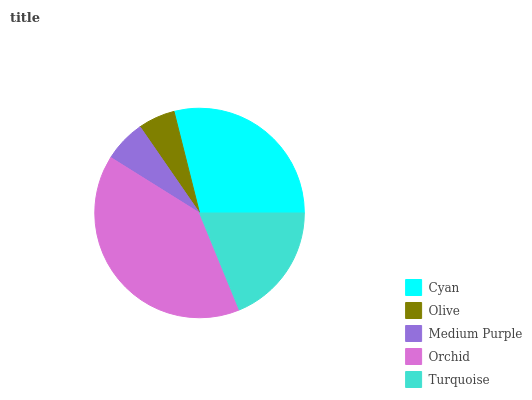Is Olive the minimum?
Answer yes or no. Yes. Is Orchid the maximum?
Answer yes or no. Yes. Is Medium Purple the minimum?
Answer yes or no. No. Is Medium Purple the maximum?
Answer yes or no. No. Is Medium Purple greater than Olive?
Answer yes or no. Yes. Is Olive less than Medium Purple?
Answer yes or no. Yes. Is Olive greater than Medium Purple?
Answer yes or no. No. Is Medium Purple less than Olive?
Answer yes or no. No. Is Turquoise the high median?
Answer yes or no. Yes. Is Turquoise the low median?
Answer yes or no. Yes. Is Medium Purple the high median?
Answer yes or no. No. Is Medium Purple the low median?
Answer yes or no. No. 